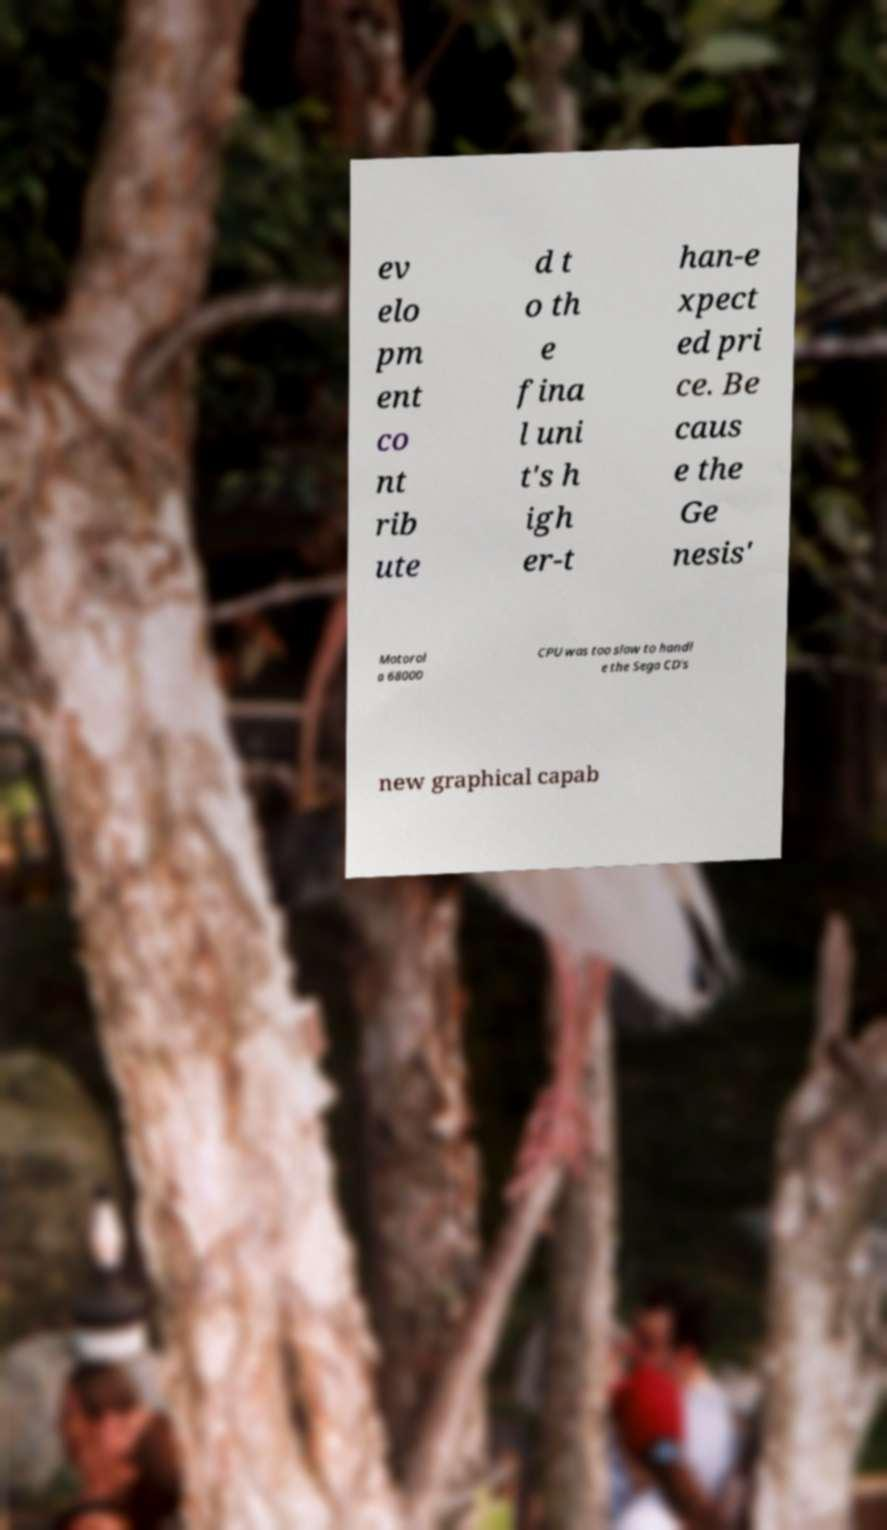Please read and relay the text visible in this image. What does it say? ev elo pm ent co nt rib ute d t o th e fina l uni t's h igh er-t han-e xpect ed pri ce. Be caus e the Ge nesis' Motorol a 68000 CPU was too slow to handl e the Sega CD's new graphical capab 